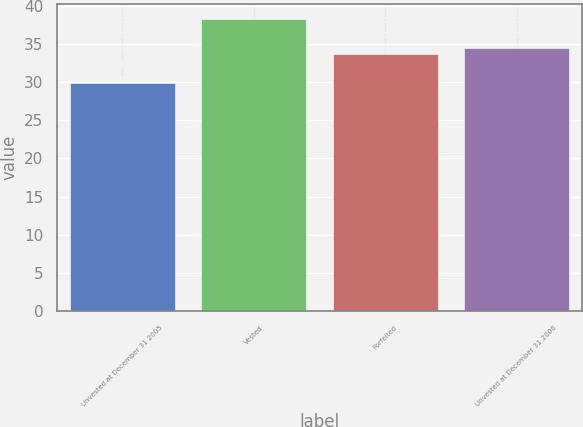<chart> <loc_0><loc_0><loc_500><loc_500><bar_chart><fcel>Unvested at December 31 2005<fcel>Vested<fcel>Forfeited<fcel>Unvested at December 31 2006<nl><fcel>29.93<fcel>38.3<fcel>33.61<fcel>34.45<nl></chart> 